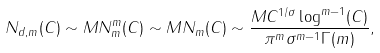Convert formula to latex. <formula><loc_0><loc_0><loc_500><loc_500>N _ { d , m } ( C ) \sim M N _ { m } ^ { m } ( C ) \sim M N _ { m } ( C ) \sim \frac { M C ^ { 1 / \sigma } \log ^ { m - 1 } ( C ) } { \pi ^ { m } \sigma ^ { m - 1 } \Gamma ( m ) } ,</formula> 